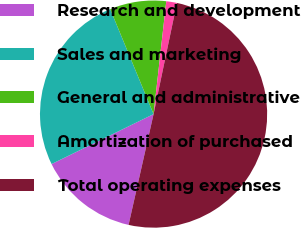<chart> <loc_0><loc_0><loc_500><loc_500><pie_chart><fcel>Research and development<fcel>Sales and marketing<fcel>General and administrative<fcel>Amortization of purchased<fcel>Total operating expenses<nl><fcel>14.22%<fcel>26.01%<fcel>8.02%<fcel>1.51%<fcel>50.24%<nl></chart> 